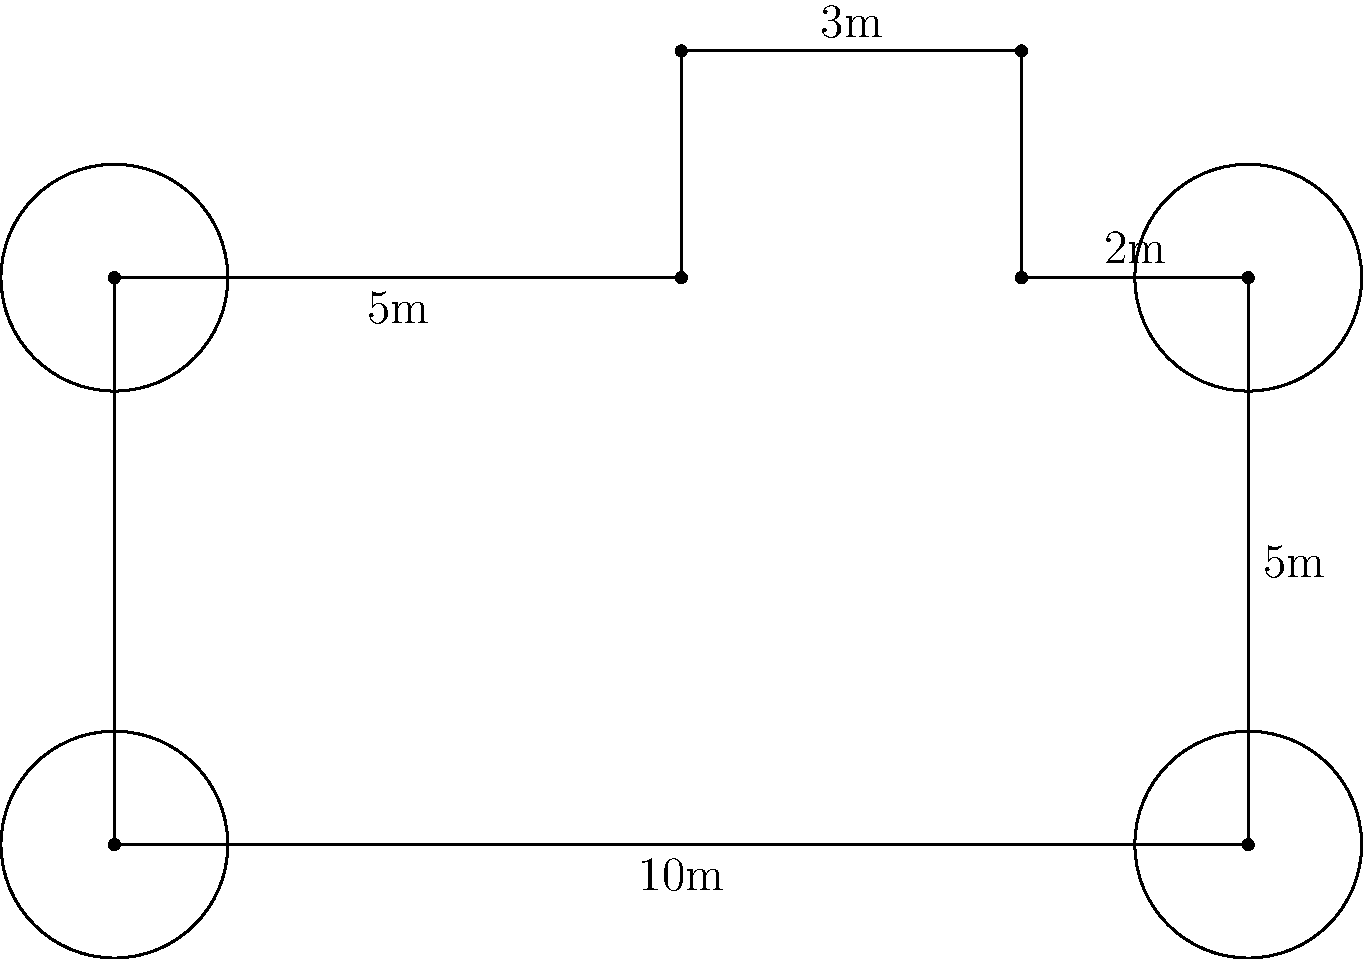Auld Stirling Castle, a historic gem of Scotland, has a simplified floor plan as shown above. The circular towers at each corner have a radius of 1 meter. Calculate the perimeter of this castle's floor plan, including the circumference of the towers. Round your answer to the nearest whole number. Let's calculate the perimeter step by step:

1. Main rectangle:
   Length = 10m, Width = 5m
   Perimeter of rectangle = $2(10 + 5) = 30m$

2. Additional rectangles:
   Top left: $3m + 2m = 5m$
   Top right: $2m + 2m = 4m$

3. Subtract the parts where towers connect:
   $4 \times 2m = 8m$ (2m for each tower)

4. Add circumference of towers:
   Circumference of one tower = $2\pi r = 2\pi \times 1 = 2\pi$
   For 4 towers: $4 \times 2\pi = 8\pi$

5. Total perimeter:
   $30m + 5m + 4m - 8m + 8\pi m = 31 + 8\pi m$

6. Calculate and round:
   $31 + 8\pi \approx 31 + 25.13 = 56.13m$

Rounded to the nearest whole number: 56m
Answer: 56m 